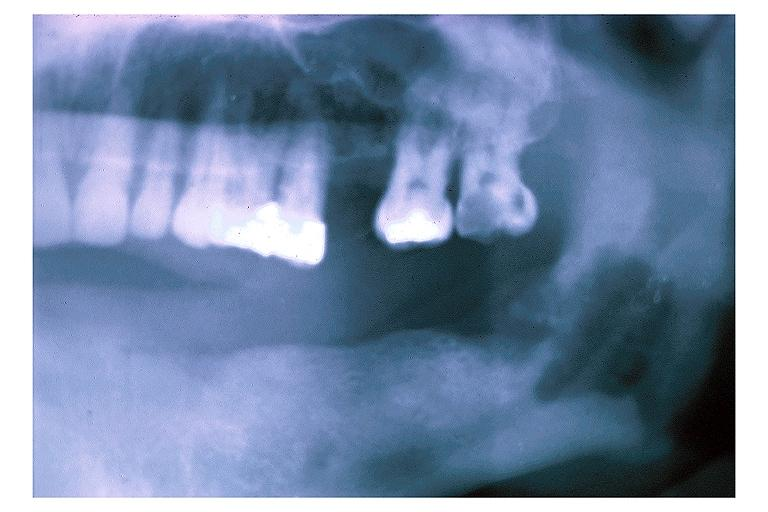s oral present?
Answer the question using a single word or phrase. Yes 